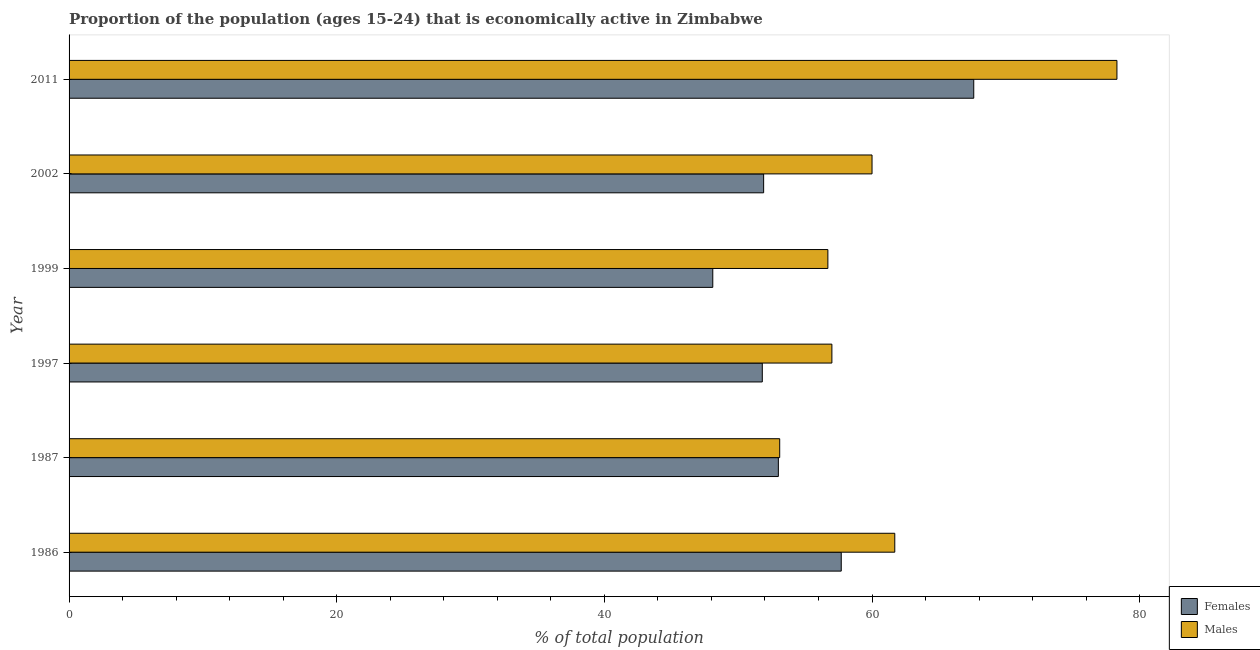How many bars are there on the 5th tick from the top?
Offer a very short reply. 2. How many bars are there on the 5th tick from the bottom?
Offer a terse response. 2. What is the label of the 1st group of bars from the top?
Provide a short and direct response. 2011. In how many cases, is the number of bars for a given year not equal to the number of legend labels?
Ensure brevity in your answer.  0. What is the percentage of economically active male population in 2002?
Offer a terse response. 60. Across all years, what is the maximum percentage of economically active male population?
Offer a very short reply. 78.3. Across all years, what is the minimum percentage of economically active male population?
Offer a terse response. 53.1. In which year was the percentage of economically active male population minimum?
Ensure brevity in your answer.  1987. What is the total percentage of economically active female population in the graph?
Your answer should be very brief. 330.1. What is the difference between the percentage of economically active female population in 1997 and that in 2011?
Keep it short and to the point. -15.8. What is the difference between the percentage of economically active male population in 1986 and the percentage of economically active female population in 2011?
Ensure brevity in your answer.  -5.9. What is the average percentage of economically active female population per year?
Keep it short and to the point. 55.02. What is the ratio of the percentage of economically active male population in 1997 to that in 1999?
Your answer should be compact. 1. What is the difference between the highest and the lowest percentage of economically active male population?
Ensure brevity in your answer.  25.2. Is the sum of the percentage of economically active male population in 2002 and 2011 greater than the maximum percentage of economically active female population across all years?
Your answer should be compact. Yes. What does the 2nd bar from the top in 2002 represents?
Offer a terse response. Females. What does the 1st bar from the bottom in 1999 represents?
Offer a very short reply. Females. How many bars are there?
Keep it short and to the point. 12. Are all the bars in the graph horizontal?
Offer a terse response. Yes. How many years are there in the graph?
Provide a short and direct response. 6. What is the difference between two consecutive major ticks on the X-axis?
Provide a short and direct response. 20. Are the values on the major ticks of X-axis written in scientific E-notation?
Your answer should be compact. No. Does the graph contain any zero values?
Your answer should be very brief. No. Does the graph contain grids?
Offer a terse response. No. How many legend labels are there?
Provide a short and direct response. 2. What is the title of the graph?
Offer a terse response. Proportion of the population (ages 15-24) that is economically active in Zimbabwe. Does "Education" appear as one of the legend labels in the graph?
Make the answer very short. No. What is the label or title of the X-axis?
Your response must be concise. % of total population. What is the label or title of the Y-axis?
Offer a terse response. Year. What is the % of total population of Females in 1986?
Keep it short and to the point. 57.7. What is the % of total population in Males in 1986?
Your response must be concise. 61.7. What is the % of total population of Males in 1987?
Give a very brief answer. 53.1. What is the % of total population of Females in 1997?
Your answer should be compact. 51.8. What is the % of total population of Males in 1997?
Your answer should be compact. 57. What is the % of total population in Females in 1999?
Ensure brevity in your answer.  48.1. What is the % of total population of Males in 1999?
Keep it short and to the point. 56.7. What is the % of total population of Females in 2002?
Your answer should be very brief. 51.9. What is the % of total population in Males in 2002?
Provide a short and direct response. 60. What is the % of total population of Females in 2011?
Your answer should be very brief. 67.6. What is the % of total population of Males in 2011?
Offer a very short reply. 78.3. Across all years, what is the maximum % of total population of Females?
Keep it short and to the point. 67.6. Across all years, what is the maximum % of total population of Males?
Ensure brevity in your answer.  78.3. Across all years, what is the minimum % of total population of Females?
Provide a short and direct response. 48.1. Across all years, what is the minimum % of total population of Males?
Your answer should be compact. 53.1. What is the total % of total population in Females in the graph?
Your response must be concise. 330.1. What is the total % of total population in Males in the graph?
Offer a very short reply. 366.8. What is the difference between the % of total population in Females in 1986 and that in 1999?
Make the answer very short. 9.6. What is the difference between the % of total population of Males in 1986 and that in 2002?
Keep it short and to the point. 1.7. What is the difference between the % of total population in Females in 1986 and that in 2011?
Your answer should be compact. -9.9. What is the difference between the % of total population of Males in 1986 and that in 2011?
Ensure brevity in your answer.  -16.6. What is the difference between the % of total population of Males in 1987 and that in 1997?
Offer a terse response. -3.9. What is the difference between the % of total population of Males in 1987 and that in 2002?
Your response must be concise. -6.9. What is the difference between the % of total population of Females in 1987 and that in 2011?
Make the answer very short. -14.6. What is the difference between the % of total population of Males in 1987 and that in 2011?
Ensure brevity in your answer.  -25.2. What is the difference between the % of total population in Females in 1997 and that in 2002?
Make the answer very short. -0.1. What is the difference between the % of total population of Males in 1997 and that in 2002?
Provide a short and direct response. -3. What is the difference between the % of total population of Females in 1997 and that in 2011?
Your answer should be compact. -15.8. What is the difference between the % of total population of Males in 1997 and that in 2011?
Provide a short and direct response. -21.3. What is the difference between the % of total population of Males in 1999 and that in 2002?
Provide a short and direct response. -3.3. What is the difference between the % of total population in Females in 1999 and that in 2011?
Give a very brief answer. -19.5. What is the difference between the % of total population of Males in 1999 and that in 2011?
Provide a succinct answer. -21.6. What is the difference between the % of total population of Females in 2002 and that in 2011?
Make the answer very short. -15.7. What is the difference between the % of total population of Males in 2002 and that in 2011?
Give a very brief answer. -18.3. What is the difference between the % of total population in Females in 1986 and the % of total population in Males in 1987?
Keep it short and to the point. 4.6. What is the difference between the % of total population of Females in 1986 and the % of total population of Males in 2011?
Provide a short and direct response. -20.6. What is the difference between the % of total population in Females in 1987 and the % of total population in Males in 1997?
Offer a terse response. -4. What is the difference between the % of total population in Females in 1987 and the % of total population in Males in 1999?
Your response must be concise. -3.7. What is the difference between the % of total population of Females in 1987 and the % of total population of Males in 2011?
Make the answer very short. -25.3. What is the difference between the % of total population in Females in 1997 and the % of total population in Males in 1999?
Your response must be concise. -4.9. What is the difference between the % of total population in Females in 1997 and the % of total population in Males in 2002?
Your answer should be compact. -8.2. What is the difference between the % of total population in Females in 1997 and the % of total population in Males in 2011?
Provide a succinct answer. -26.5. What is the difference between the % of total population in Females in 1999 and the % of total population in Males in 2011?
Offer a very short reply. -30.2. What is the difference between the % of total population in Females in 2002 and the % of total population in Males in 2011?
Provide a short and direct response. -26.4. What is the average % of total population of Females per year?
Offer a very short reply. 55.02. What is the average % of total population of Males per year?
Your response must be concise. 61.13. In the year 2011, what is the difference between the % of total population in Females and % of total population in Males?
Provide a short and direct response. -10.7. What is the ratio of the % of total population of Females in 1986 to that in 1987?
Provide a short and direct response. 1.09. What is the ratio of the % of total population in Males in 1986 to that in 1987?
Provide a succinct answer. 1.16. What is the ratio of the % of total population in Females in 1986 to that in 1997?
Provide a short and direct response. 1.11. What is the ratio of the % of total population in Males in 1986 to that in 1997?
Your answer should be very brief. 1.08. What is the ratio of the % of total population in Females in 1986 to that in 1999?
Provide a short and direct response. 1.2. What is the ratio of the % of total population in Males in 1986 to that in 1999?
Your answer should be very brief. 1.09. What is the ratio of the % of total population in Females in 1986 to that in 2002?
Ensure brevity in your answer.  1.11. What is the ratio of the % of total population in Males in 1986 to that in 2002?
Your response must be concise. 1.03. What is the ratio of the % of total population in Females in 1986 to that in 2011?
Your response must be concise. 0.85. What is the ratio of the % of total population of Males in 1986 to that in 2011?
Provide a succinct answer. 0.79. What is the ratio of the % of total population in Females in 1987 to that in 1997?
Offer a terse response. 1.02. What is the ratio of the % of total population in Males in 1987 to that in 1997?
Give a very brief answer. 0.93. What is the ratio of the % of total population of Females in 1987 to that in 1999?
Give a very brief answer. 1.1. What is the ratio of the % of total population of Males in 1987 to that in 1999?
Give a very brief answer. 0.94. What is the ratio of the % of total population of Females in 1987 to that in 2002?
Keep it short and to the point. 1.02. What is the ratio of the % of total population of Males in 1987 to that in 2002?
Your answer should be very brief. 0.89. What is the ratio of the % of total population in Females in 1987 to that in 2011?
Your response must be concise. 0.78. What is the ratio of the % of total population in Males in 1987 to that in 2011?
Your response must be concise. 0.68. What is the ratio of the % of total population in Females in 1997 to that in 1999?
Provide a succinct answer. 1.08. What is the ratio of the % of total population in Females in 1997 to that in 2002?
Keep it short and to the point. 1. What is the ratio of the % of total population of Males in 1997 to that in 2002?
Offer a very short reply. 0.95. What is the ratio of the % of total population of Females in 1997 to that in 2011?
Ensure brevity in your answer.  0.77. What is the ratio of the % of total population in Males in 1997 to that in 2011?
Give a very brief answer. 0.73. What is the ratio of the % of total population of Females in 1999 to that in 2002?
Ensure brevity in your answer.  0.93. What is the ratio of the % of total population of Males in 1999 to that in 2002?
Provide a succinct answer. 0.94. What is the ratio of the % of total population of Females in 1999 to that in 2011?
Make the answer very short. 0.71. What is the ratio of the % of total population in Males in 1999 to that in 2011?
Provide a succinct answer. 0.72. What is the ratio of the % of total population of Females in 2002 to that in 2011?
Your response must be concise. 0.77. What is the ratio of the % of total population in Males in 2002 to that in 2011?
Offer a terse response. 0.77. What is the difference between the highest and the second highest % of total population of Females?
Make the answer very short. 9.9. What is the difference between the highest and the second highest % of total population of Males?
Your response must be concise. 16.6. What is the difference between the highest and the lowest % of total population of Males?
Offer a very short reply. 25.2. 